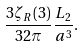Convert formula to latex. <formula><loc_0><loc_0><loc_500><loc_500>\frac { 3 \zeta _ { R } ( 3 ) } { 3 2 \pi } \frac { L _ { 2 } } { a ^ { 3 } } .</formula> 